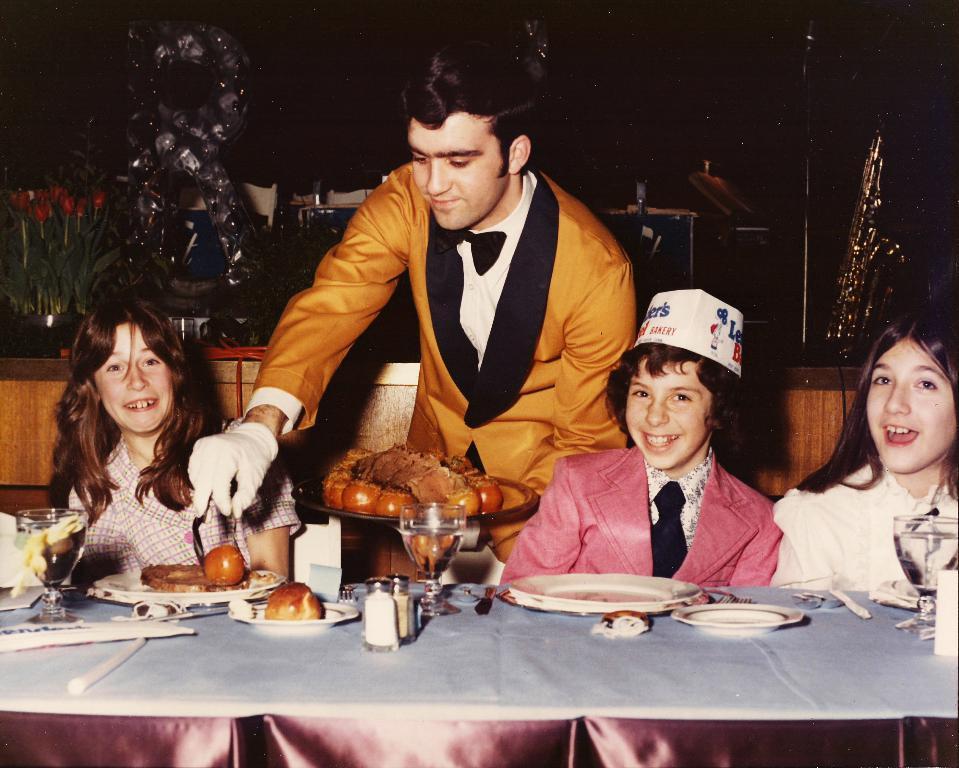Describe this image in one or two sentences. In this image in the center there are three children who are sitting on chairs, in front of them there is one table. On the table there are some plates, glasses, salt and pepper and some fruits. In the center there is one man who is standing, and he is serving the food to the children. In the background there are some lights, flower, bouquets and wall. 